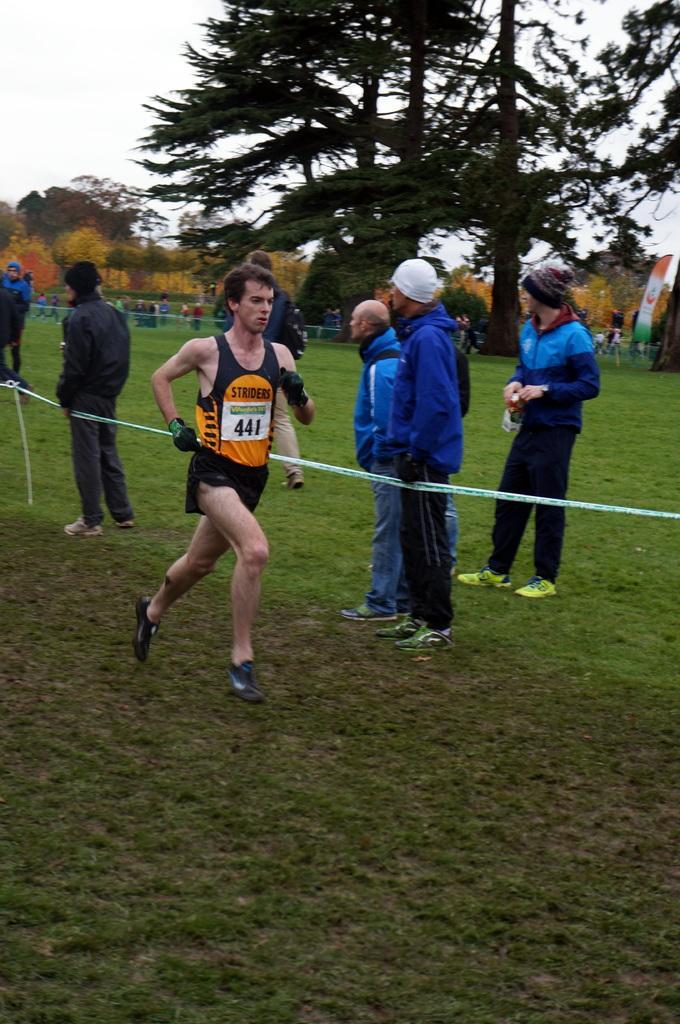Could you give a brief overview of what you see in this image? In this picture there is a man who is running on the grass. Beside him I can see many people who are standing near to the rope. In the background I can see the tent, fencing, trees, plants and grass. And some people are standing near to the trees. At the top left I can see the sky. 